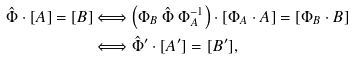Convert formula to latex. <formula><loc_0><loc_0><loc_500><loc_500>\hat { \Phi } \cdot [ A ] = [ B ] & \Longleftrightarrow \left ( \Phi _ { B } \ \hat { \Phi } \ \Phi _ { A } ^ { - 1 } \right ) \cdot [ \Phi _ { A } \cdot A ] = [ \Phi _ { B } \cdot B ] \\ & \Longleftrightarrow \hat { \Phi } ^ { \prime } \cdot [ A ^ { \prime } ] = [ B ^ { \prime } ] ,</formula> 